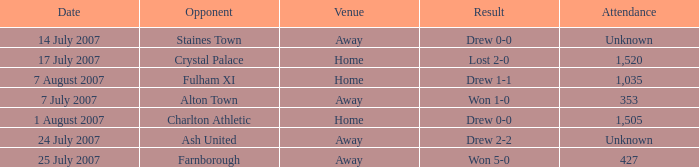Could you parse the entire table? {'header': ['Date', 'Opponent', 'Venue', 'Result', 'Attendance'], 'rows': [['14 July 2007', 'Staines Town', 'Away', 'Drew 0-0', 'Unknown'], ['17 July 2007', 'Crystal Palace', 'Home', 'Lost 2-0', '1,520'], ['7 August 2007', 'Fulham XI', 'Home', 'Drew 1-1', '1,035'], ['7 July 2007', 'Alton Town', 'Away', 'Won 1-0', '353'], ['1 August 2007', 'Charlton Athletic', 'Home', 'Drew 0-0', '1,505'], ['24 July 2007', 'Ash United', 'Away', 'Drew 2-2', 'Unknown'], ['25 July 2007', 'Farnborough', 'Away', 'Won 5-0', '427']]} Name the venue for staines town Away. 